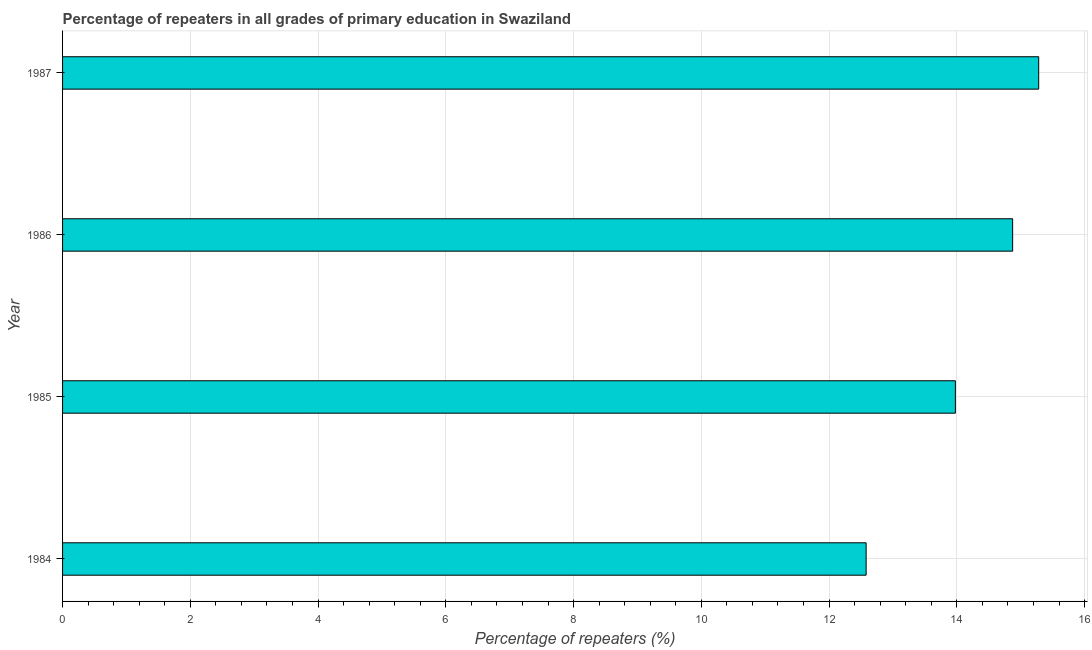Does the graph contain grids?
Offer a very short reply. Yes. What is the title of the graph?
Your response must be concise. Percentage of repeaters in all grades of primary education in Swaziland. What is the label or title of the X-axis?
Give a very brief answer. Percentage of repeaters (%). What is the percentage of repeaters in primary education in 1984?
Ensure brevity in your answer.  12.58. Across all years, what is the maximum percentage of repeaters in primary education?
Ensure brevity in your answer.  15.28. Across all years, what is the minimum percentage of repeaters in primary education?
Your answer should be very brief. 12.58. In which year was the percentage of repeaters in primary education maximum?
Your response must be concise. 1987. In which year was the percentage of repeaters in primary education minimum?
Ensure brevity in your answer.  1984. What is the sum of the percentage of repeaters in primary education?
Provide a short and direct response. 56.71. What is the difference between the percentage of repeaters in primary education in 1984 and 1985?
Your answer should be very brief. -1.4. What is the average percentage of repeaters in primary education per year?
Give a very brief answer. 14.18. What is the median percentage of repeaters in primary education?
Give a very brief answer. 14.43. In how many years, is the percentage of repeaters in primary education greater than 10.4 %?
Ensure brevity in your answer.  4. Do a majority of the years between 1986 and 1984 (inclusive) have percentage of repeaters in primary education greater than 7.6 %?
Ensure brevity in your answer.  Yes. What is the difference between the highest and the second highest percentage of repeaters in primary education?
Make the answer very short. 0.41. Is the sum of the percentage of repeaters in primary education in 1984 and 1986 greater than the maximum percentage of repeaters in primary education across all years?
Give a very brief answer. Yes. In how many years, is the percentage of repeaters in primary education greater than the average percentage of repeaters in primary education taken over all years?
Offer a very short reply. 2. How many bars are there?
Your response must be concise. 4. Are all the bars in the graph horizontal?
Give a very brief answer. Yes. How many years are there in the graph?
Give a very brief answer. 4. Are the values on the major ticks of X-axis written in scientific E-notation?
Your answer should be very brief. No. What is the Percentage of repeaters (%) in 1984?
Ensure brevity in your answer.  12.58. What is the Percentage of repeaters (%) in 1985?
Offer a terse response. 13.98. What is the Percentage of repeaters (%) of 1986?
Make the answer very short. 14.87. What is the Percentage of repeaters (%) in 1987?
Your response must be concise. 15.28. What is the difference between the Percentage of repeaters (%) in 1984 and 1985?
Provide a succinct answer. -1.4. What is the difference between the Percentage of repeaters (%) in 1984 and 1986?
Provide a succinct answer. -2.29. What is the difference between the Percentage of repeaters (%) in 1984 and 1987?
Your answer should be very brief. -2.7. What is the difference between the Percentage of repeaters (%) in 1985 and 1986?
Make the answer very short. -0.9. What is the difference between the Percentage of repeaters (%) in 1985 and 1987?
Your answer should be very brief. -1.3. What is the difference between the Percentage of repeaters (%) in 1986 and 1987?
Offer a very short reply. -0.41. What is the ratio of the Percentage of repeaters (%) in 1984 to that in 1986?
Offer a very short reply. 0.85. What is the ratio of the Percentage of repeaters (%) in 1984 to that in 1987?
Provide a succinct answer. 0.82. What is the ratio of the Percentage of repeaters (%) in 1985 to that in 1986?
Keep it short and to the point. 0.94. What is the ratio of the Percentage of repeaters (%) in 1985 to that in 1987?
Offer a terse response. 0.92. What is the ratio of the Percentage of repeaters (%) in 1986 to that in 1987?
Provide a succinct answer. 0.97. 